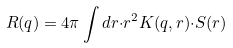Convert formula to latex. <formula><loc_0><loc_0><loc_500><loc_500>R ( q ) = 4 \pi \int { d r } { \cdot } r ^ { 2 } K ( q , r ) { \cdot } S ( r )</formula> 